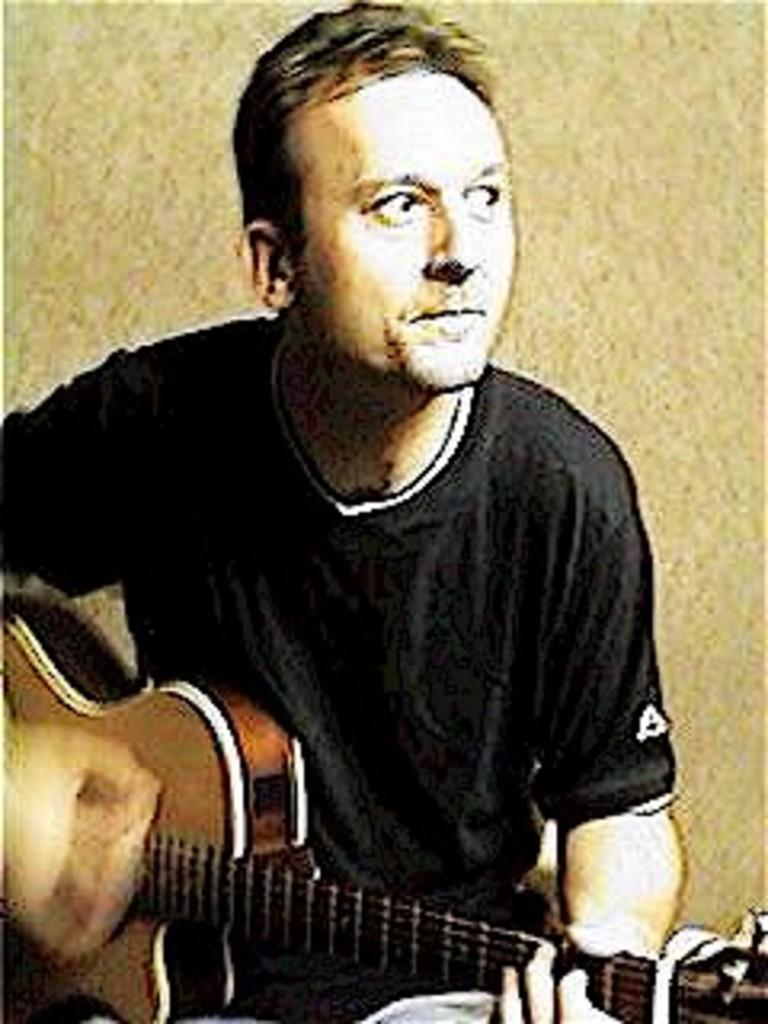Who is present in the image? There is a man in the image. What is the man doing in the image? The man is sitting in the image. What object is the man holding in the image? The man is holding a guitar in his hands. What type of caption is written on the guitar in the image? There is no caption written on the guitar in the image. 